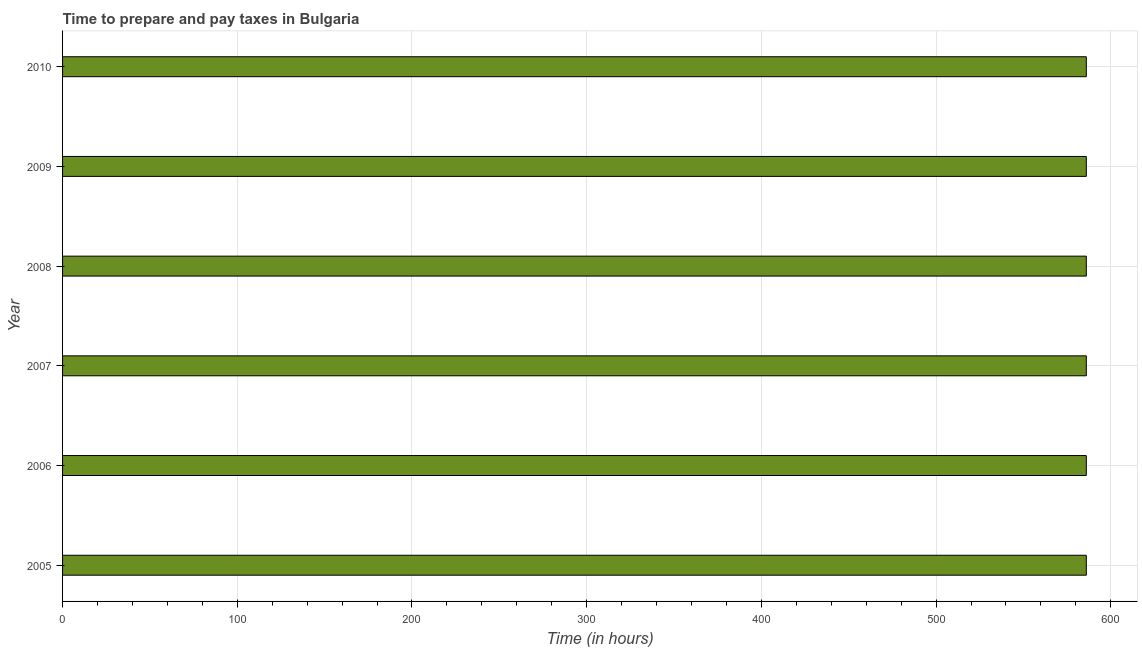Does the graph contain any zero values?
Your answer should be very brief. No. Does the graph contain grids?
Ensure brevity in your answer.  Yes. What is the title of the graph?
Offer a very short reply. Time to prepare and pay taxes in Bulgaria. What is the label or title of the X-axis?
Ensure brevity in your answer.  Time (in hours). What is the time to prepare and pay taxes in 2007?
Provide a succinct answer. 586. Across all years, what is the maximum time to prepare and pay taxes?
Provide a short and direct response. 586. Across all years, what is the minimum time to prepare and pay taxes?
Provide a succinct answer. 586. What is the sum of the time to prepare and pay taxes?
Keep it short and to the point. 3516. What is the difference between the time to prepare and pay taxes in 2009 and 2010?
Offer a terse response. 0. What is the average time to prepare and pay taxes per year?
Make the answer very short. 586. What is the median time to prepare and pay taxes?
Provide a succinct answer. 586. In how many years, is the time to prepare and pay taxes greater than 360 hours?
Give a very brief answer. 6. Is the time to prepare and pay taxes in 2005 less than that in 2008?
Offer a terse response. No. In how many years, is the time to prepare and pay taxes greater than the average time to prepare and pay taxes taken over all years?
Offer a very short reply. 0. How many years are there in the graph?
Ensure brevity in your answer.  6. What is the difference between two consecutive major ticks on the X-axis?
Your answer should be compact. 100. Are the values on the major ticks of X-axis written in scientific E-notation?
Give a very brief answer. No. What is the Time (in hours) of 2005?
Give a very brief answer. 586. What is the Time (in hours) in 2006?
Give a very brief answer. 586. What is the Time (in hours) of 2007?
Keep it short and to the point. 586. What is the Time (in hours) in 2008?
Provide a short and direct response. 586. What is the Time (in hours) in 2009?
Provide a succinct answer. 586. What is the Time (in hours) of 2010?
Your response must be concise. 586. What is the difference between the Time (in hours) in 2005 and 2006?
Make the answer very short. 0. What is the difference between the Time (in hours) in 2005 and 2007?
Give a very brief answer. 0. What is the difference between the Time (in hours) in 2005 and 2008?
Offer a very short reply. 0. What is the difference between the Time (in hours) in 2005 and 2009?
Make the answer very short. 0. What is the difference between the Time (in hours) in 2005 and 2010?
Offer a very short reply. 0. What is the difference between the Time (in hours) in 2006 and 2008?
Your answer should be very brief. 0. What is the difference between the Time (in hours) in 2007 and 2010?
Give a very brief answer. 0. What is the difference between the Time (in hours) in 2009 and 2010?
Keep it short and to the point. 0. What is the ratio of the Time (in hours) in 2005 to that in 2008?
Provide a short and direct response. 1. What is the ratio of the Time (in hours) in 2005 to that in 2009?
Keep it short and to the point. 1. What is the ratio of the Time (in hours) in 2006 to that in 2007?
Provide a succinct answer. 1. What is the ratio of the Time (in hours) in 2007 to that in 2009?
Offer a very short reply. 1. What is the ratio of the Time (in hours) in 2008 to that in 2010?
Give a very brief answer. 1. 